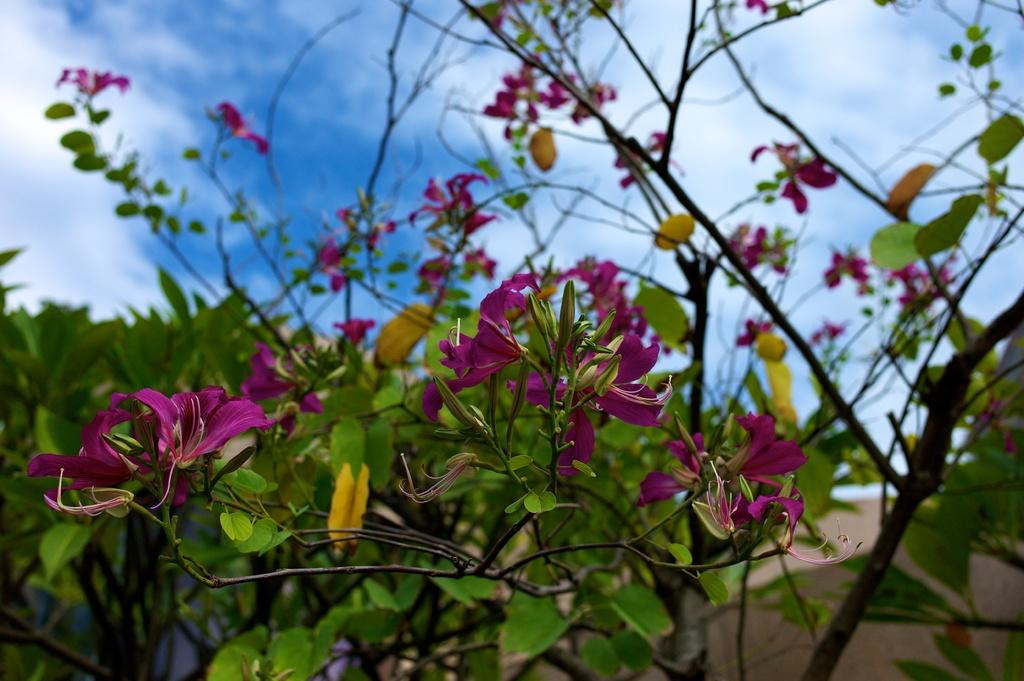What is the main subject of the image? There is a group of flowers in the image. What else can be seen in the image besides the flowers? There are leaves on branches and a group of trees in the background of the image. What is visible in the background of the image? There is a wall and the sky visible in the background of the image. Can you see any giants in the image? There are no giants present in the image. What type of space vehicle can be seen in the image? There is no space vehicle present in the image; it features a group of flowers, leaves on branches, trees, a wall, and the sky. 